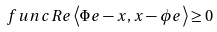Convert formula to latex. <formula><loc_0><loc_0><loc_500><loc_500>\ f u n c { R e } \left \langle \Phi e - x , x - \phi e \right \rangle \geq 0</formula> 